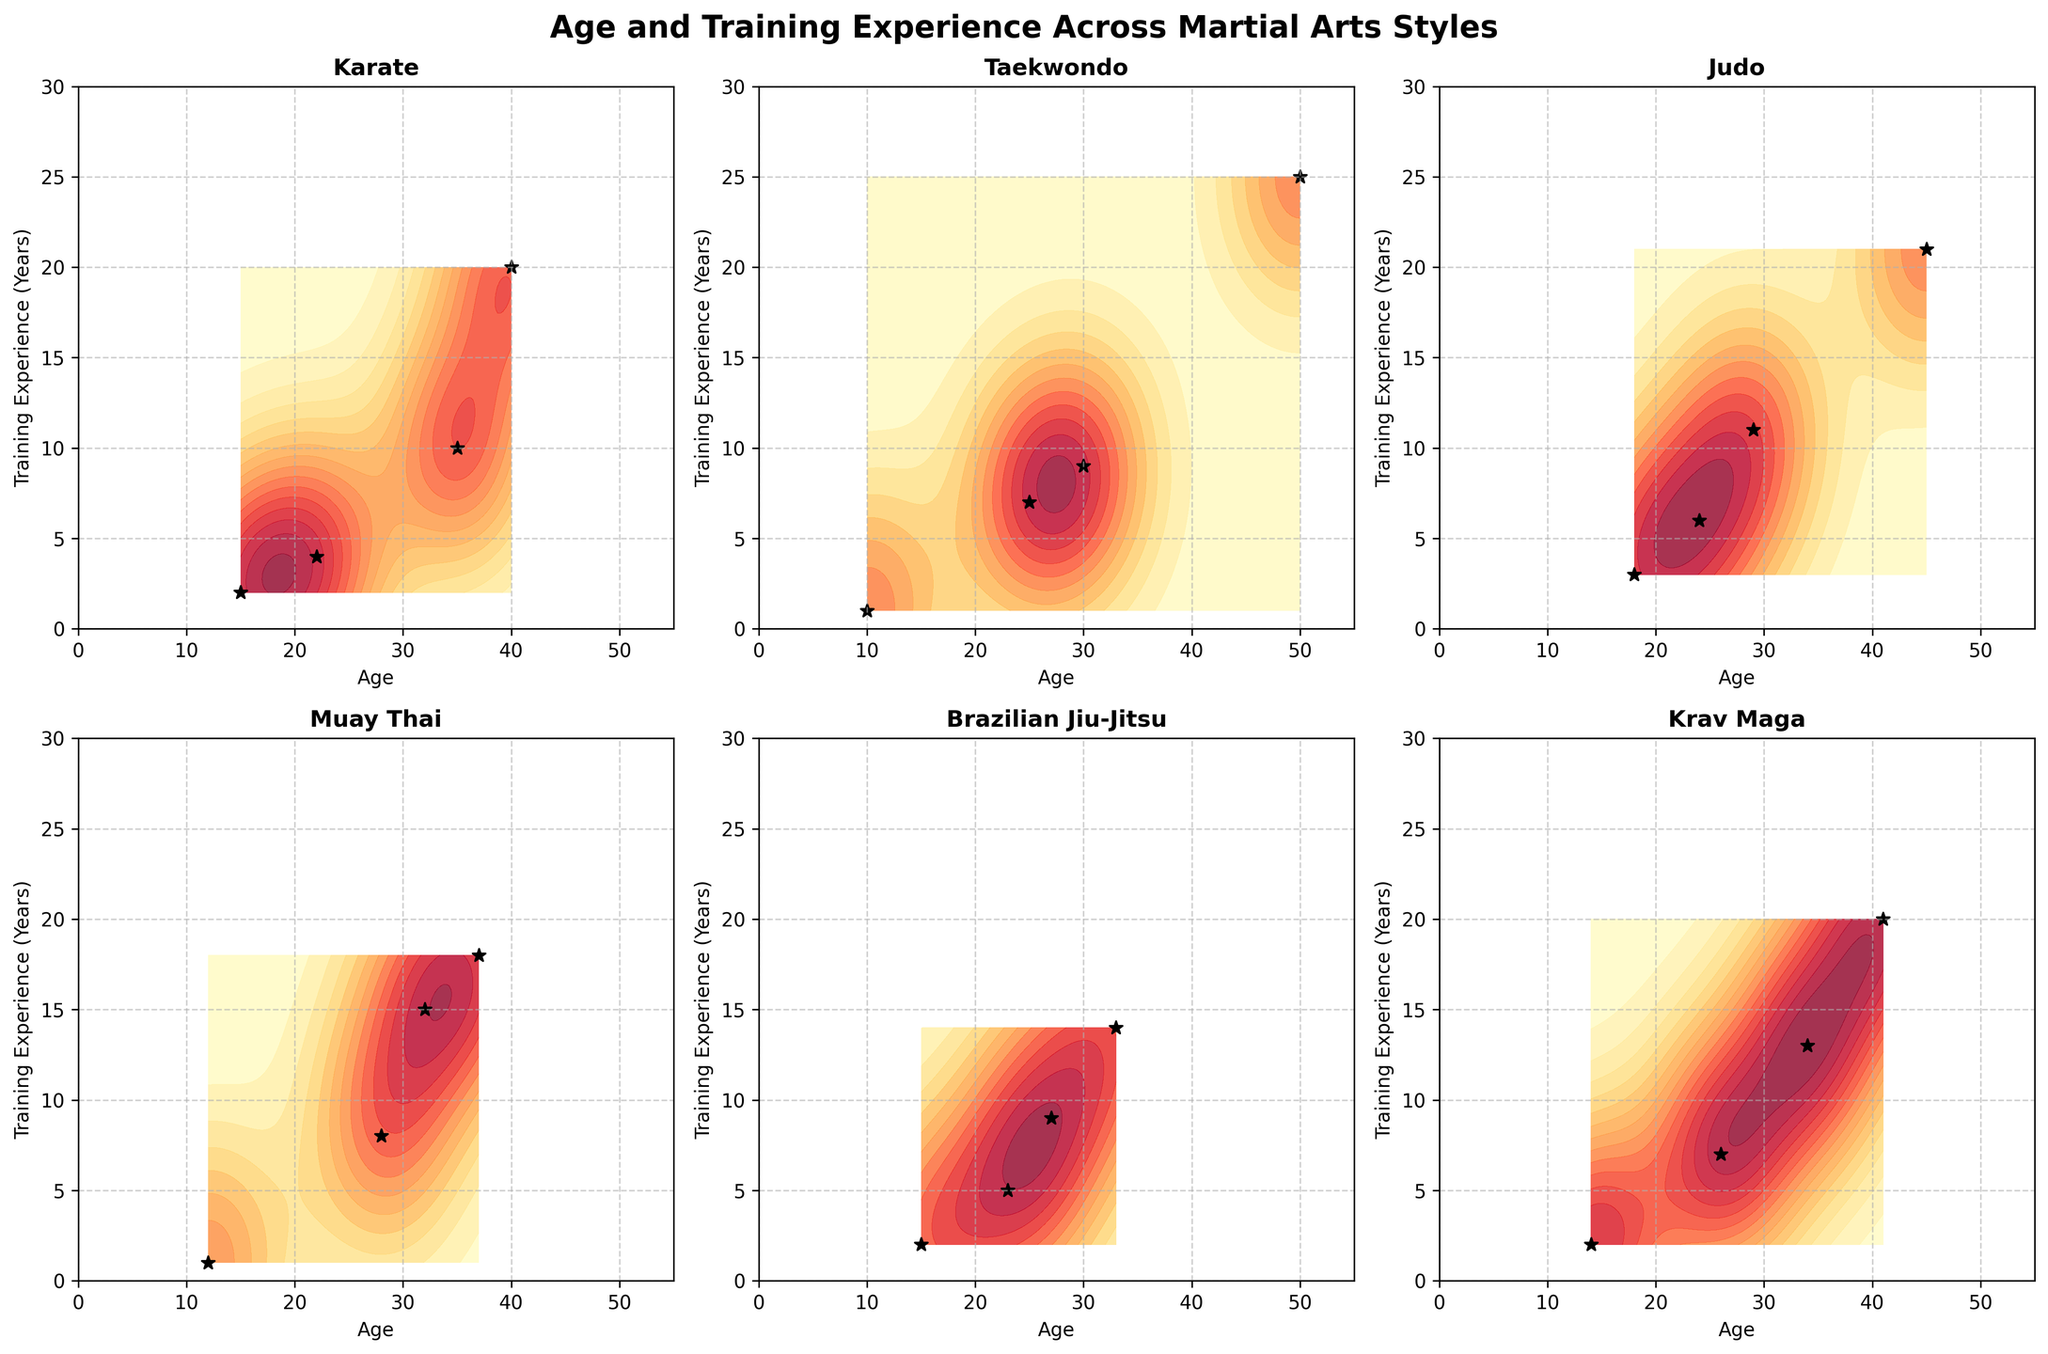What is the title of the figure? The title of the figure is displayed at the top of the plot, showing a concise description of what the figure represents. In this case, it's about demographics of martial arts practitioners based on age and training experience.
Answer: Age and Training Experience Across Martial Arts Styles Which martial arts style has practitioners with the highest training experience? Look at the subplots and identify the contour plot that shows the highest values on the "Training Experience (Years)" axis.
Answer: Taekwondo How many martial arts styles are compared in the figure? Count the number of subplots, each representing a different martial arts style.
Answer: 6 What is the age range of Karate practitioners? Find the subplot for Karate and identify the minimum and maximum values on the "Age" axis for the data points.
Answer: 15-40 Which martial arts style has the largest spread in age among its practitioners? Compare the age range in each subplot. The largest spread will be the difference between the maximum and minimum ages for the style with the widest range.
Answer: Krav Maga What is the average age of Brazilian Jiu-Jitsu practitioners based on the data points? Note the ages of the Brazilian Jiu-Jitsu practitioners: 15, 23, 27, and 33. Calculate the average by summing these values and dividing by the number of data points.
Answer: 24.5 Which style has the most evenly distributed training experience among its practitioners? Look at the contour density and spread in the "Training Experience" dimension for each style to determine which style shows an even distribution.
Answer: Judo Is there a general trend in training experience as age increases among all styles? Observe the contour plots to identify if there's a pattern where training experience tends to increase with age across different styles.
Answer: Yes For which style does the youngest practitioner have the most training experience? Look at the data points for the youngest practitioners in each subplot and compare their training experience.
Answer: Karate What is the training experience range for Muay Thai practitioners? Look at the subplot for Muay Thai and identify the minimum and maximum values on the "Training Experience" axis for the data points.
Answer: 1-18 